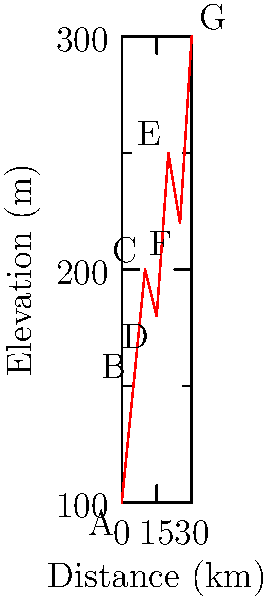The graph shows the elevation profile of a popular cycling trail in Perthshire. What is the total elevation gain of the trail? To calculate the total elevation gain, we need to sum up all the positive elevation changes between consecutive points:

1. From A to B: 150m - 100m = 50m gain
2. From B to C: 200m - 150m = 50m gain
3. From C to D: No gain (descent)
4. From D to E: 250m - 180m = 70m gain
5. From E to F: No gain (descent)
6. From F to G: 300m - 220m = 80m gain

Total elevation gain = 50m + 50m + 70m + 80m = 250m

Note: We only count positive elevation changes (gains) and ignore descents.
Answer: 250 meters 